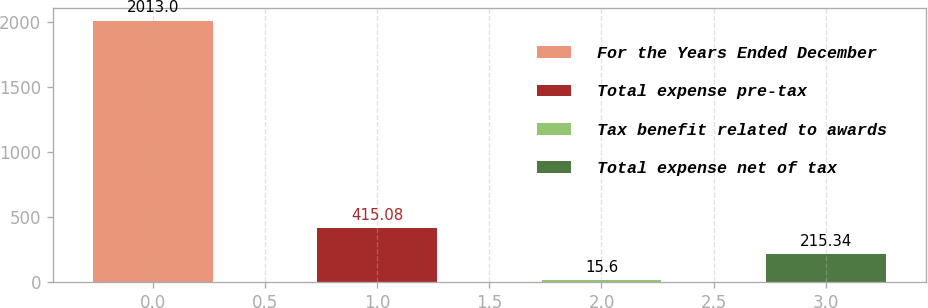Convert chart to OTSL. <chart><loc_0><loc_0><loc_500><loc_500><bar_chart><fcel>For the Years Ended December<fcel>Total expense pre-tax<fcel>Tax benefit related to awards<fcel>Total expense net of tax<nl><fcel>2013<fcel>415.08<fcel>15.6<fcel>215.34<nl></chart> 